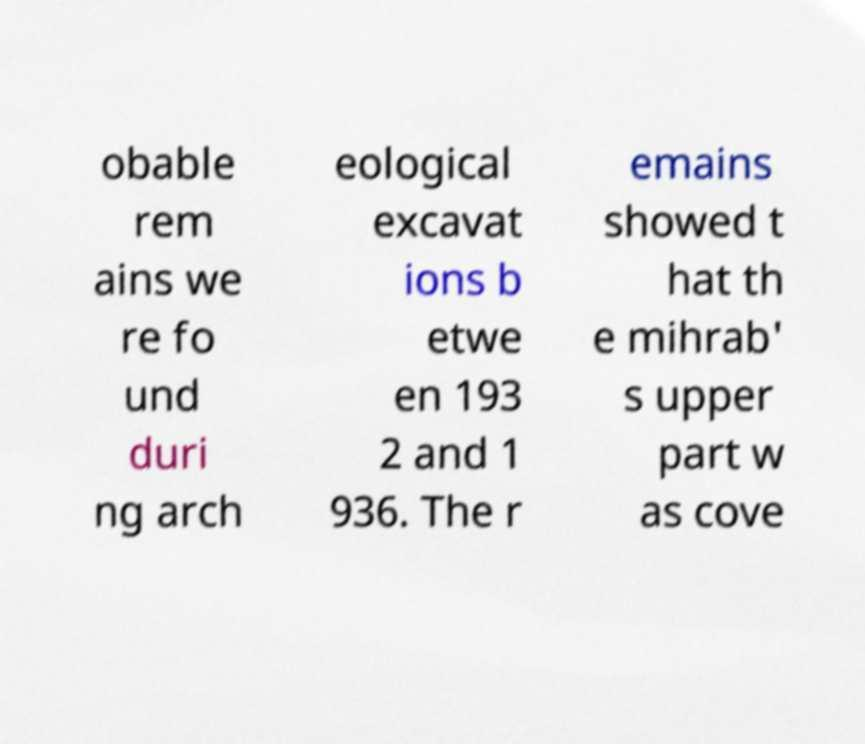I need the written content from this picture converted into text. Can you do that? obable rem ains we re fo und duri ng arch eological excavat ions b etwe en 193 2 and 1 936. The r emains showed t hat th e mihrab' s upper part w as cove 